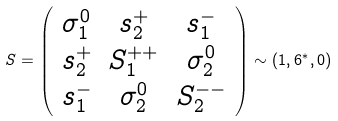Convert formula to latex. <formula><loc_0><loc_0><loc_500><loc_500>S = \left ( \begin{array} { c c c } \sigma ^ { 0 } _ { 1 } & s _ { 2 } ^ { + } & s _ { 1 } ^ { - } \\ s _ { 2 } ^ { + } & S _ { 1 } ^ { + + } & \sigma _ { 2 } ^ { 0 } \\ s _ { 1 } ^ { - } & \sigma _ { 2 } ^ { 0 } & S _ { 2 } ^ { - - } \\ \end{array} \right ) \sim \left ( { 1 } , { 6 } ^ { * } , 0 \right )</formula> 